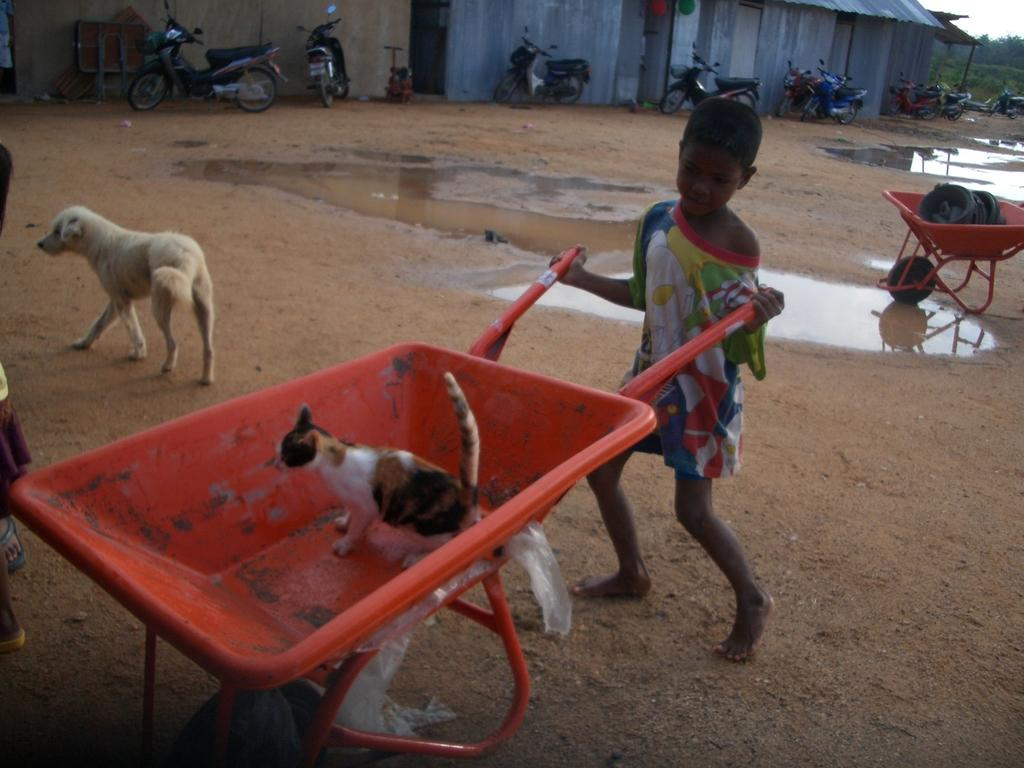What type of animals can be seen in the image? There is a cat and a dog in the image. What is the kid doing in the image? The activity of the kid cannot be determined from the provided facts. What is visible in the background of the image? There are vehicles in the background of the image. What natural element is present in the image? There is water visible in the image. What type of chairs are used by the animals in the image? There are no chairs present in the image. What type of hobbies do the animals in the image enjoy? There is no information about the animals' hobbies in the image. 